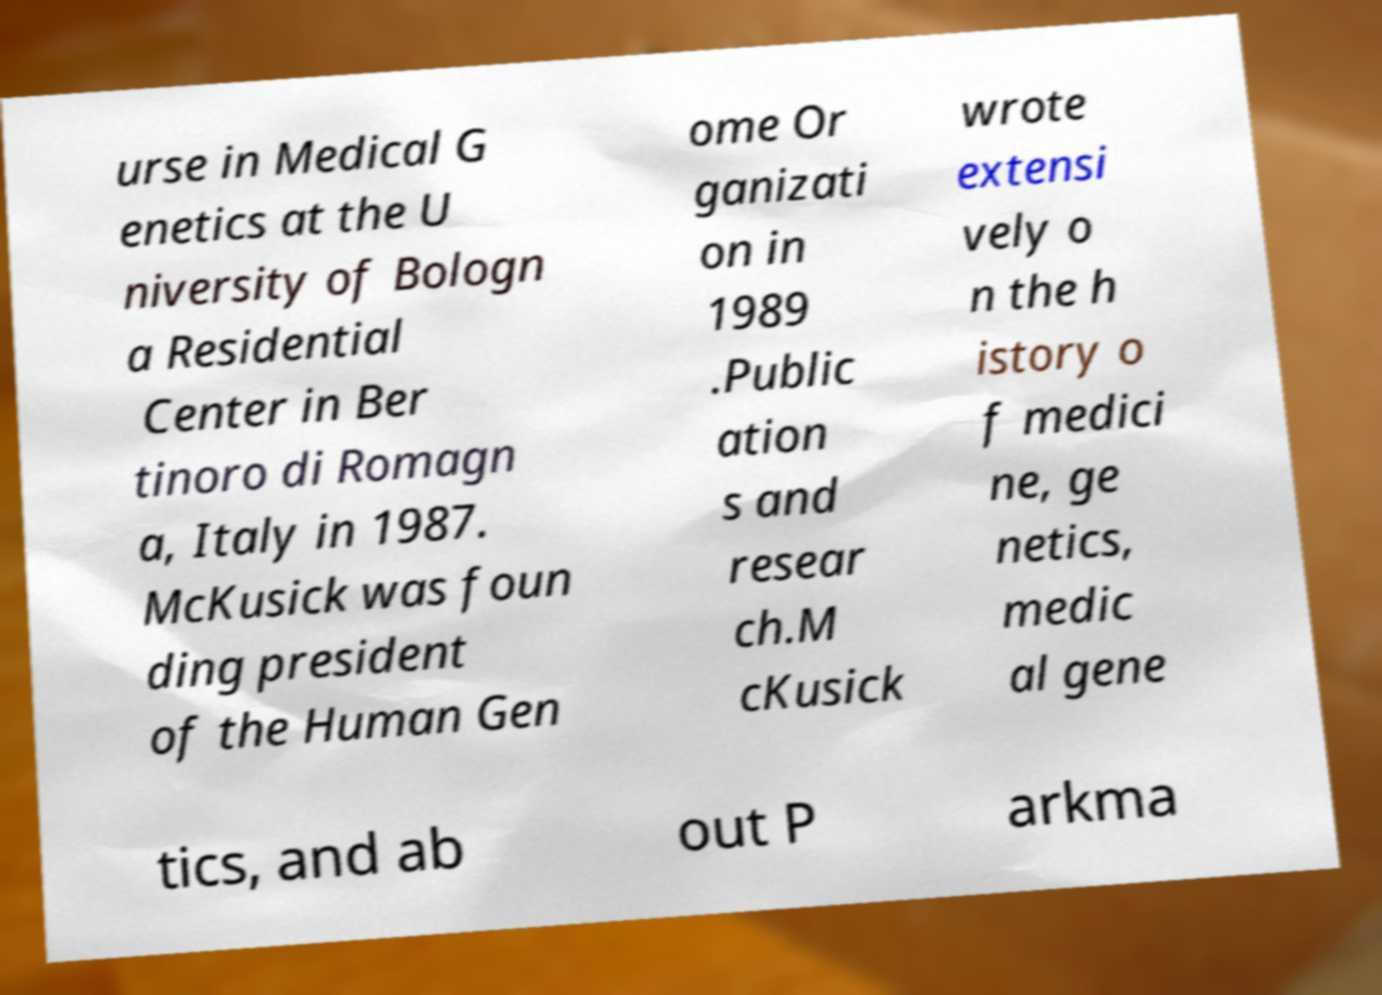What messages or text are displayed in this image? I need them in a readable, typed format. urse in Medical G enetics at the U niversity of Bologn a Residential Center in Ber tinoro di Romagn a, Italy in 1987. McKusick was foun ding president of the Human Gen ome Or ganizati on in 1989 .Public ation s and resear ch.M cKusick wrote extensi vely o n the h istory o f medici ne, ge netics, medic al gene tics, and ab out P arkma 